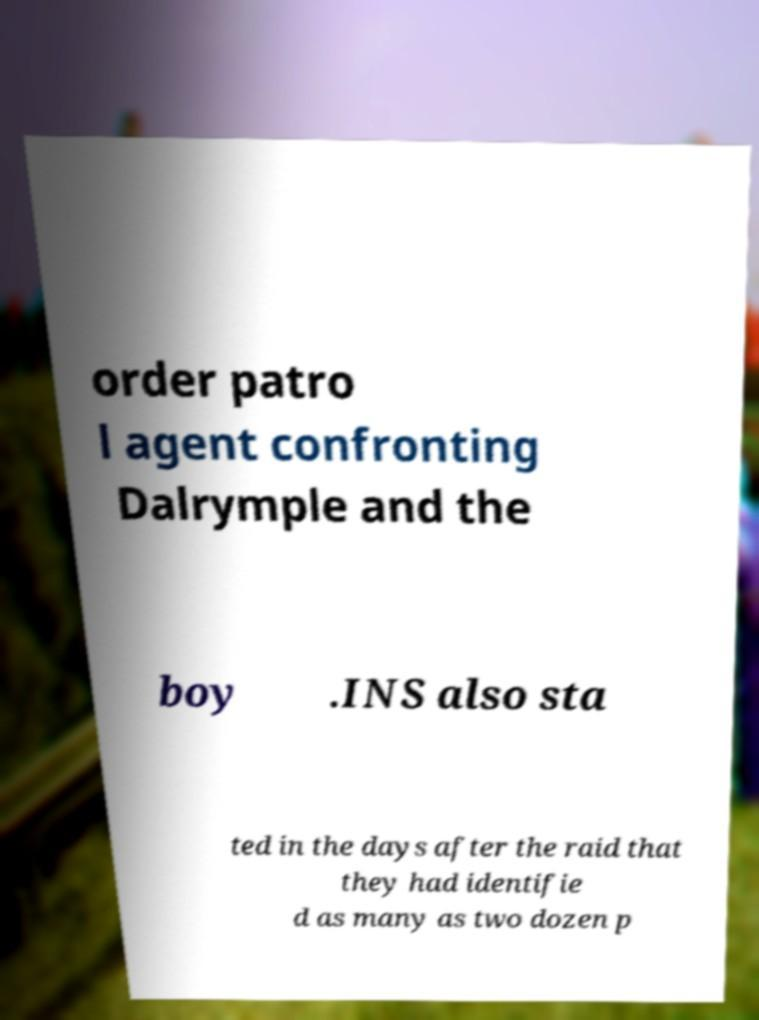Could you assist in decoding the text presented in this image and type it out clearly? order patro l agent confronting Dalrymple and the boy .INS also sta ted in the days after the raid that they had identifie d as many as two dozen p 